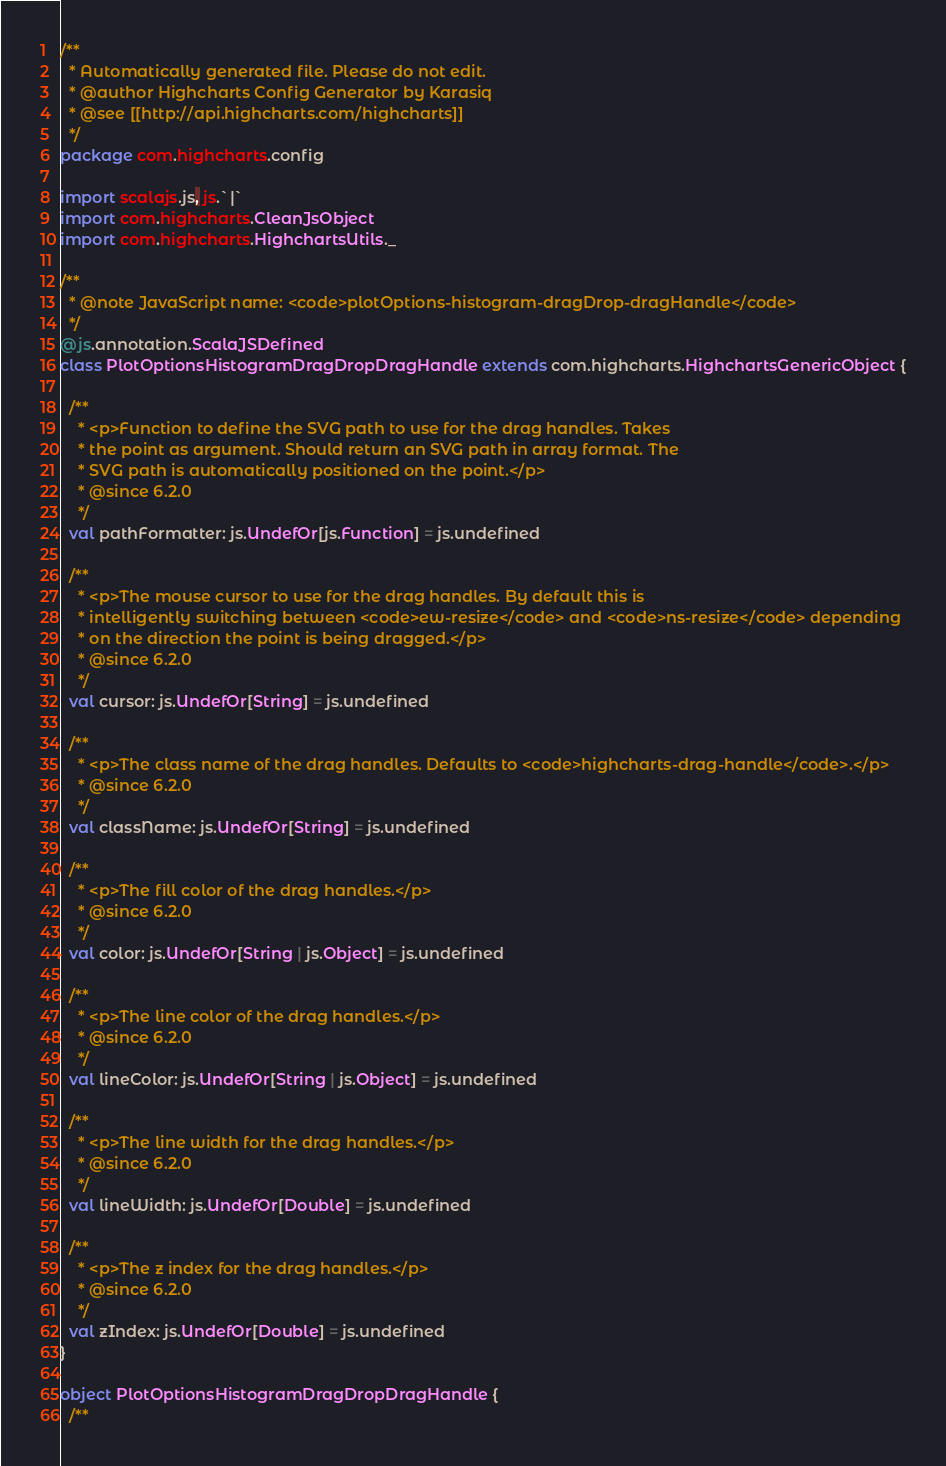<code> <loc_0><loc_0><loc_500><loc_500><_Scala_>/**
  * Automatically generated file. Please do not edit.
  * @author Highcharts Config Generator by Karasiq
  * @see [[http://api.highcharts.com/highcharts]]
  */
package com.highcharts.config

import scalajs.js, js.`|`
import com.highcharts.CleanJsObject
import com.highcharts.HighchartsUtils._

/**
  * @note JavaScript name: <code>plotOptions-histogram-dragDrop-dragHandle</code>
  */
@js.annotation.ScalaJSDefined
class PlotOptionsHistogramDragDropDragHandle extends com.highcharts.HighchartsGenericObject {

  /**
    * <p>Function to define the SVG path to use for the drag handles. Takes
    * the point as argument. Should return an SVG path in array format. The
    * SVG path is automatically positioned on the point.</p>
    * @since 6.2.0
    */
  val pathFormatter: js.UndefOr[js.Function] = js.undefined

  /**
    * <p>The mouse cursor to use for the drag handles. By default this is
    * intelligently switching between <code>ew-resize</code> and <code>ns-resize</code> depending
    * on the direction the point is being dragged.</p>
    * @since 6.2.0
    */
  val cursor: js.UndefOr[String] = js.undefined

  /**
    * <p>The class name of the drag handles. Defaults to <code>highcharts-drag-handle</code>.</p>
    * @since 6.2.0
    */
  val className: js.UndefOr[String] = js.undefined

  /**
    * <p>The fill color of the drag handles.</p>
    * @since 6.2.0
    */
  val color: js.UndefOr[String | js.Object] = js.undefined

  /**
    * <p>The line color of the drag handles.</p>
    * @since 6.2.0
    */
  val lineColor: js.UndefOr[String | js.Object] = js.undefined

  /**
    * <p>The line width for the drag handles.</p>
    * @since 6.2.0
    */
  val lineWidth: js.UndefOr[Double] = js.undefined

  /**
    * <p>The z index for the drag handles.</p>
    * @since 6.2.0
    */
  val zIndex: js.UndefOr[Double] = js.undefined
}

object PlotOptionsHistogramDragDropDragHandle {
  /**</code> 